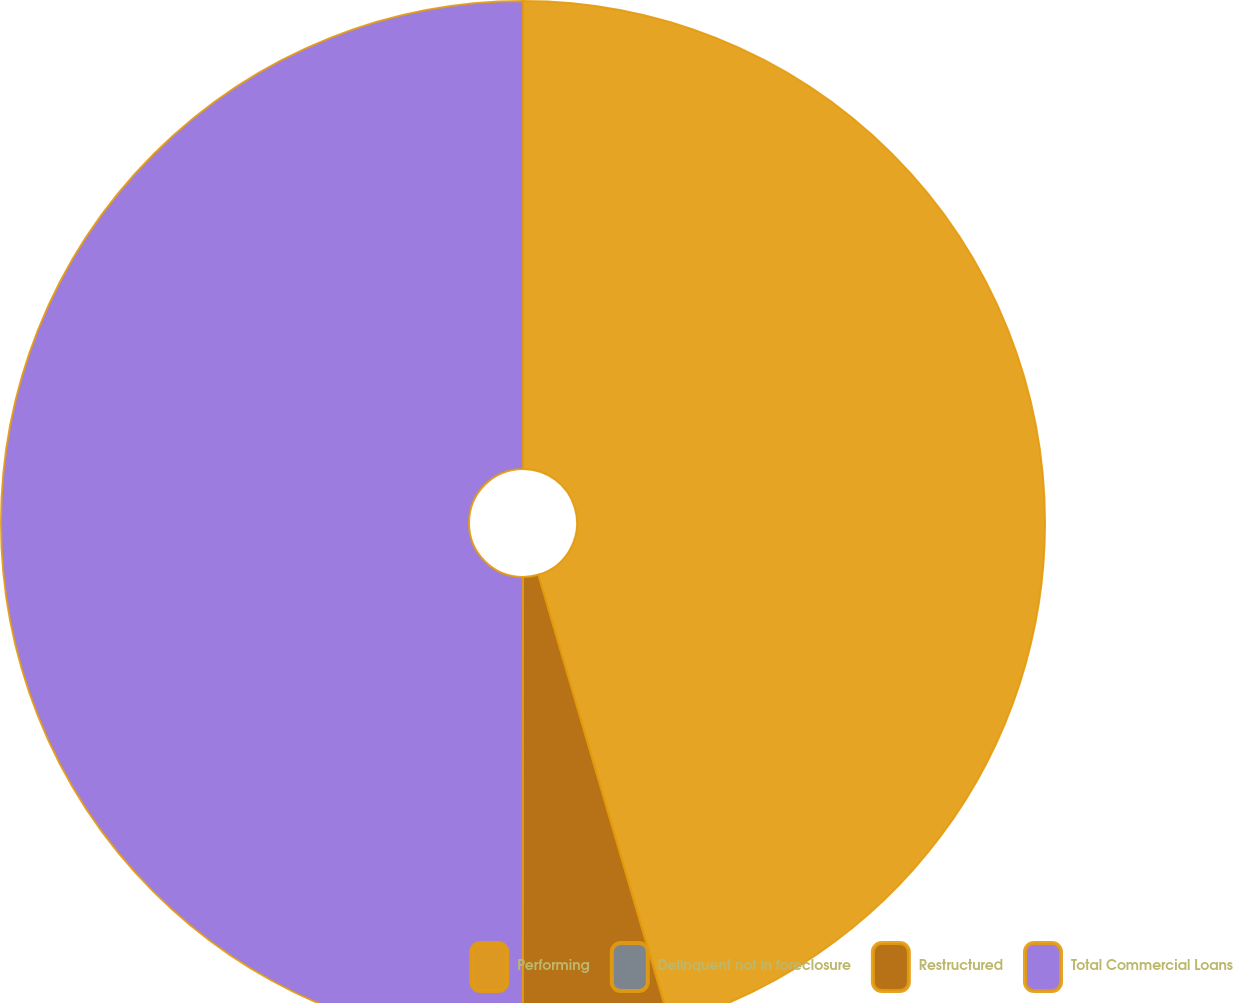<chart> <loc_0><loc_0><loc_500><loc_500><pie_chart><fcel>Performing<fcel>Delinquent not in foreclosure<fcel>Restructured<fcel>Total Commercial Loans<nl><fcel>45.45%<fcel>0.01%<fcel>4.55%<fcel>49.99%<nl></chart> 